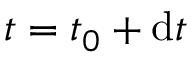<formula> <loc_0><loc_0><loc_500><loc_500>t = t _ { 0 } + d t</formula> 